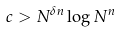Convert formula to latex. <formula><loc_0><loc_0><loc_500><loc_500>c > N ^ { \delta n } \log N ^ { n }</formula> 